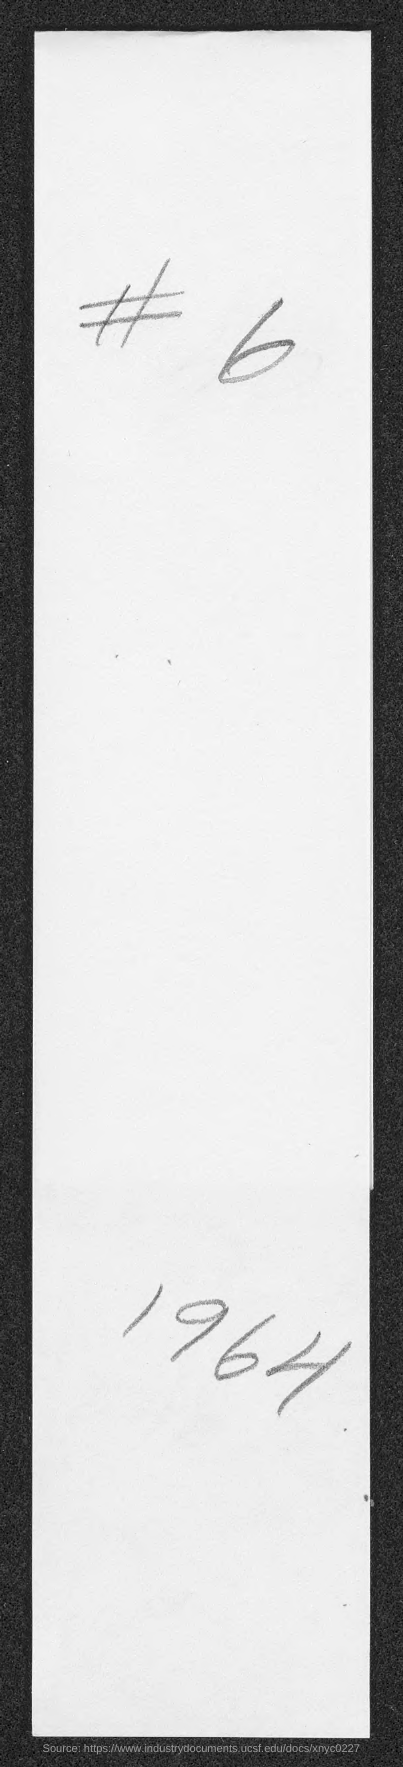Specify some key components in this picture. The symbol that is present in the document is the "#..." symbol. The document mentions a number that is 6.. The year mentioned in the document is 1964. 